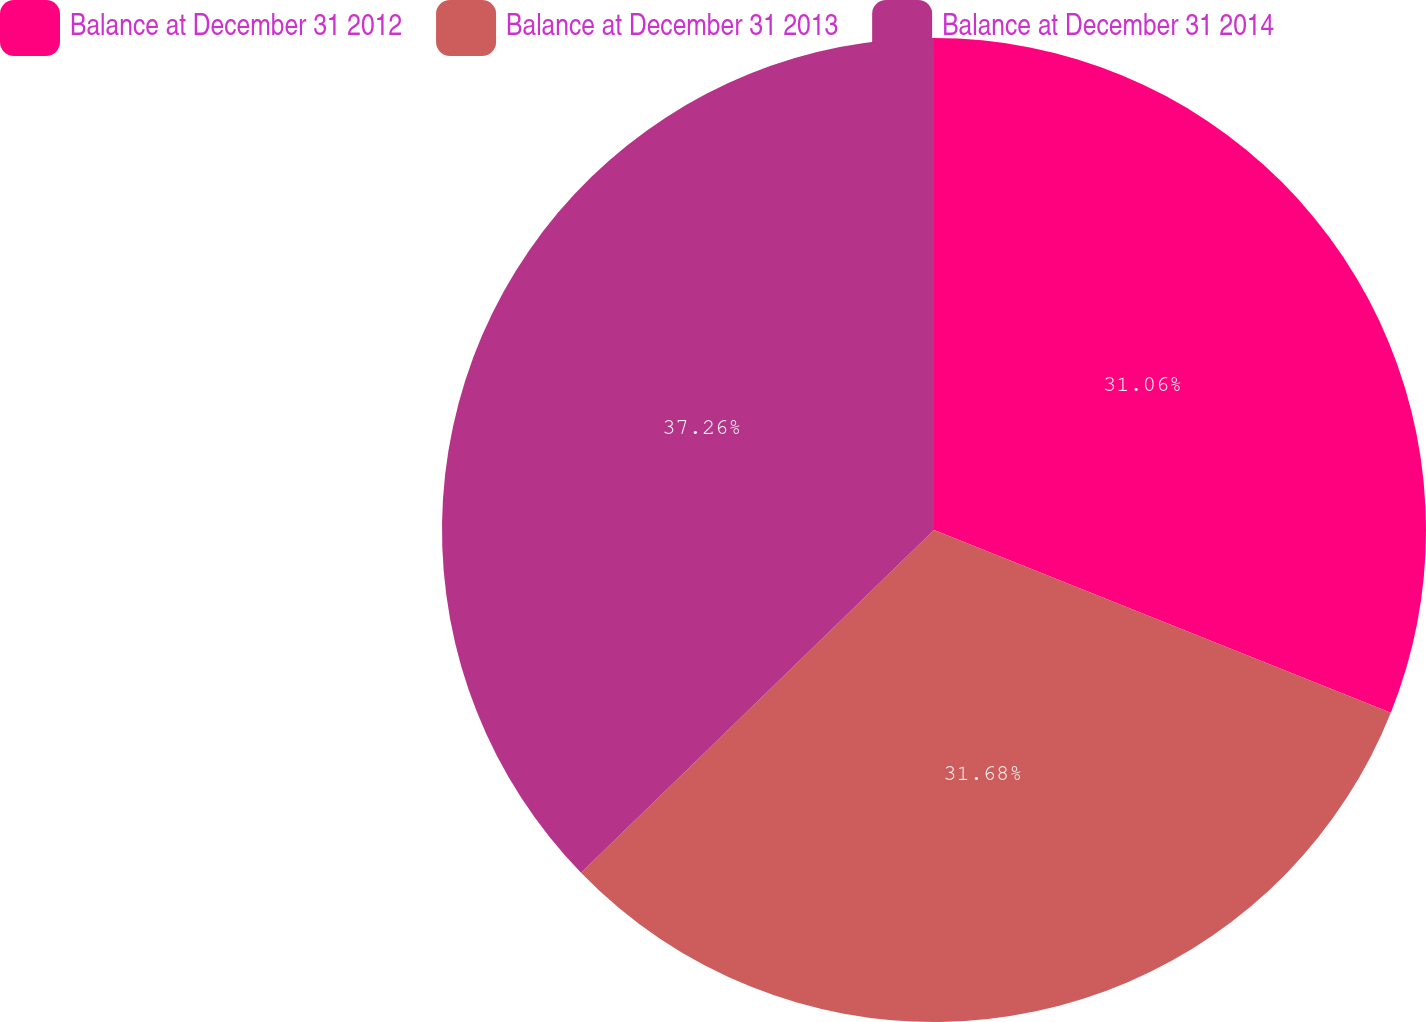<chart> <loc_0><loc_0><loc_500><loc_500><pie_chart><fcel>Balance at December 31 2012<fcel>Balance at December 31 2013<fcel>Balance at December 31 2014<nl><fcel>31.06%<fcel>31.68%<fcel>37.27%<nl></chart> 